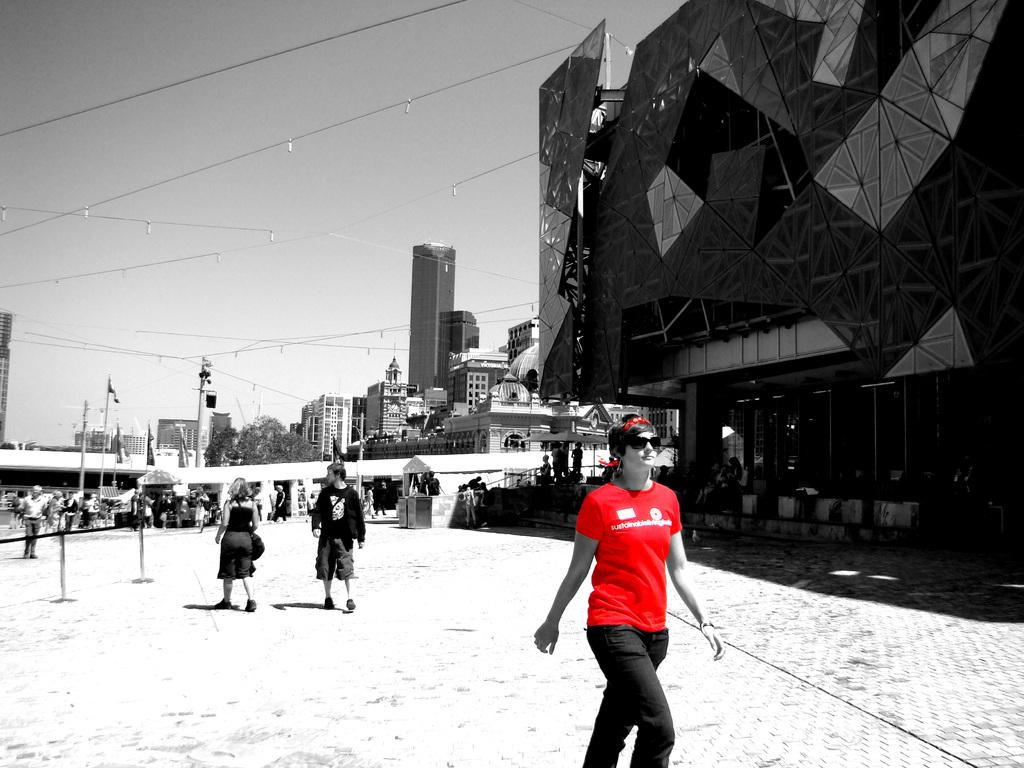What is happening on the right side of the image? There is a person walking on the right side of the image. What is the person wearing? The person is wearing a red t-shirt. What type of structure can be seen in the image? There is a building in the image. What is visible at the top of the image? The sky is visible at the top of the image. What type of haircut does the person's partner have in the image? There is no partner present in the image, so it is not possible to determine their haircut. 